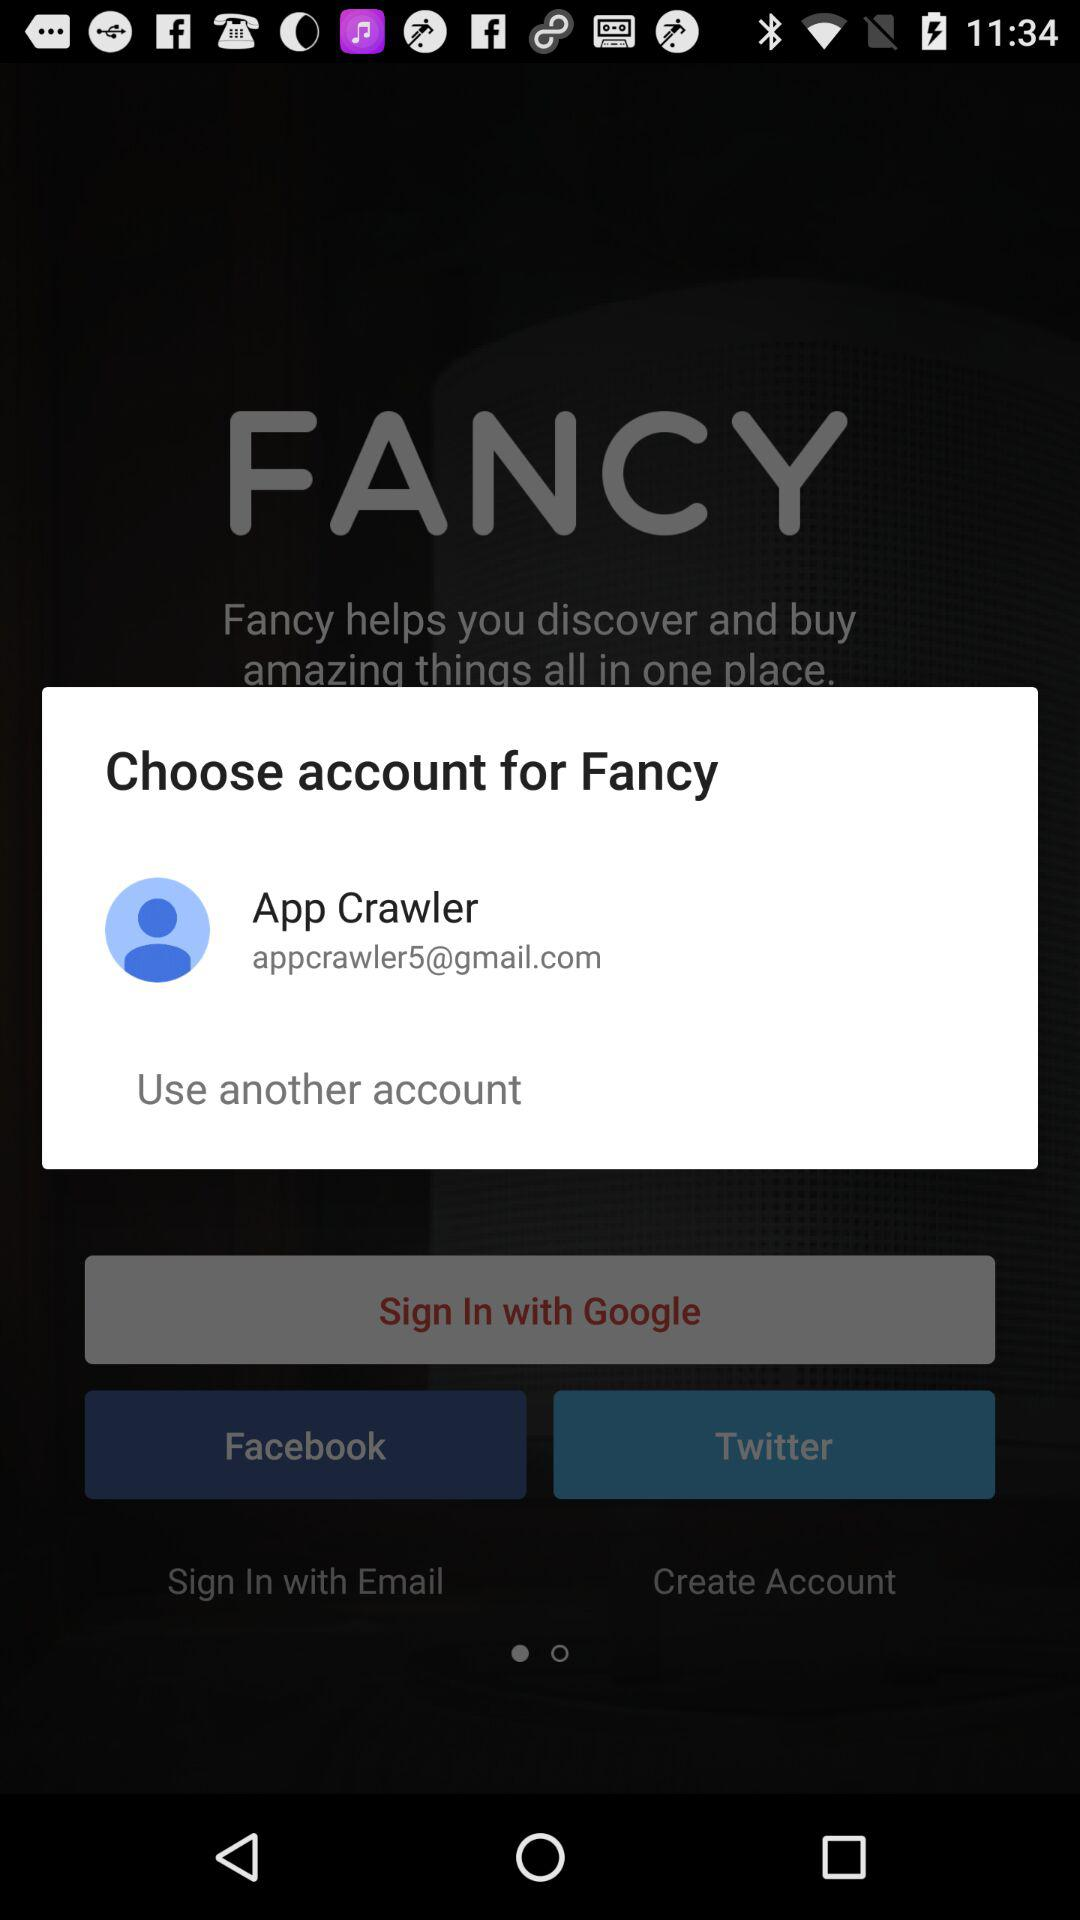What is an email address? The email address is "appcrawler5@gmail.com". 